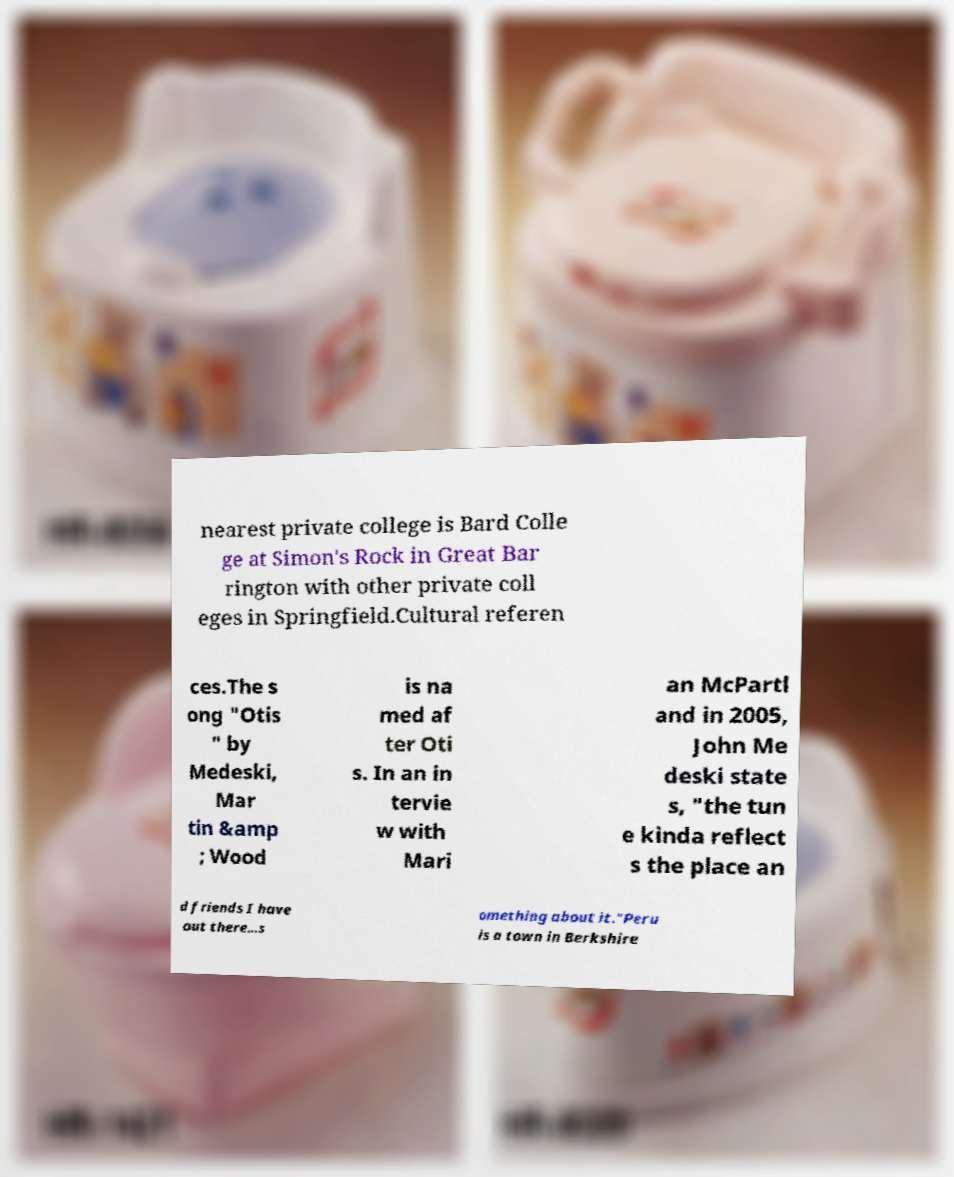There's text embedded in this image that I need extracted. Can you transcribe it verbatim? nearest private college is Bard Colle ge at Simon's Rock in Great Bar rington with other private coll eges in Springfield.Cultural referen ces.The s ong "Otis " by Medeski, Mar tin &amp ; Wood is na med af ter Oti s. In an in tervie w with Mari an McPartl and in 2005, John Me deski state s, "the tun e kinda reflect s the place an d friends I have out there...s omething about it."Peru is a town in Berkshire 